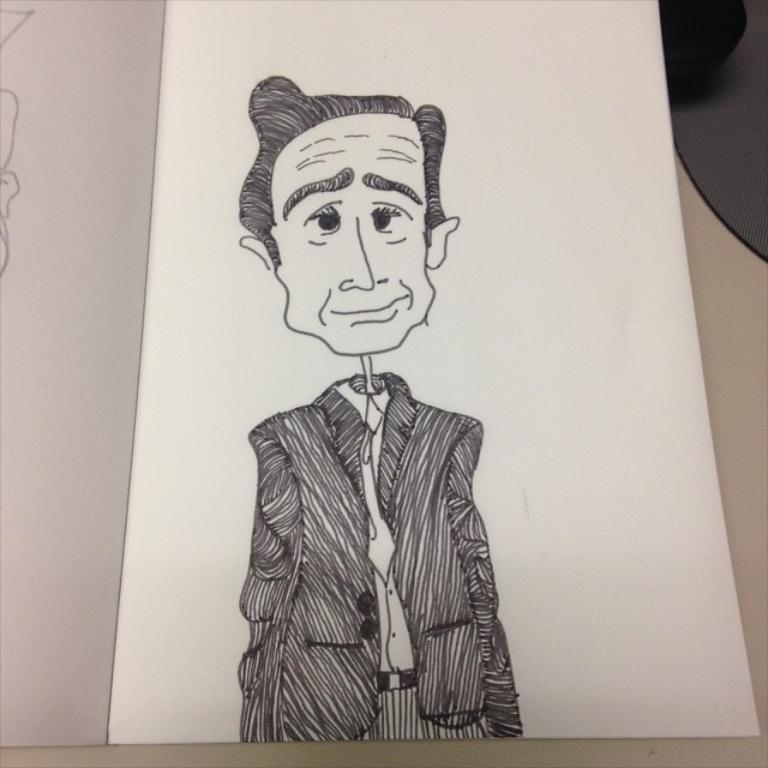What is depicted on the paper in the image? There is a sketch of a person on the paper. Can you describe the medium used for the sketch? The medium used for the sketch is not specified in the image, but it appears to be a drawing on paper. What type of punishment is being administered to the person in the sketch? There is no indication of punishment in the image; it only shows a sketch of a person on a paper. What color is the whip used in the sketch? There is no whip present in the image, as it only features a sketch of a person on a paper. 